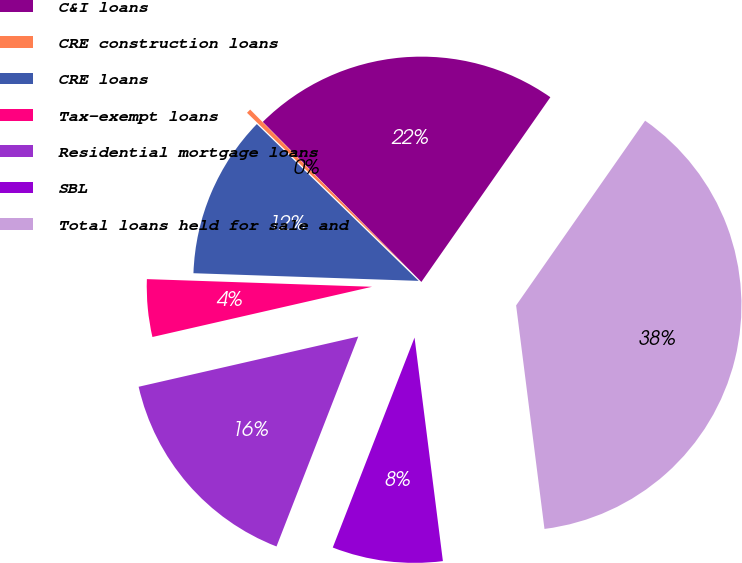Convert chart. <chart><loc_0><loc_0><loc_500><loc_500><pie_chart><fcel>C&I loans<fcel>CRE construction loans<fcel>CRE loans<fcel>Tax-exempt loans<fcel>Residential mortgage loans<fcel>SBL<fcel>Total loans held for sale and<nl><fcel>22.13%<fcel>0.32%<fcel>11.71%<fcel>4.12%<fcel>15.51%<fcel>7.92%<fcel>38.29%<nl></chart> 